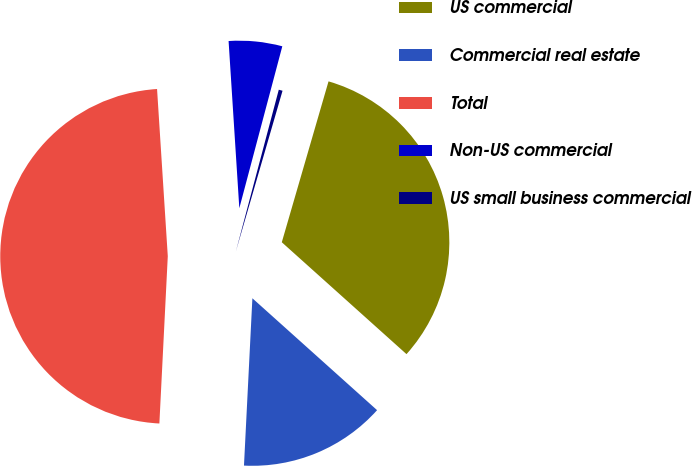<chart> <loc_0><loc_0><loc_500><loc_500><pie_chart><fcel>US commercial<fcel>Commercial real estate<fcel>Total<fcel>Non-US commercial<fcel>US small business commercial<nl><fcel>32.14%<fcel>14.16%<fcel>48.18%<fcel>5.15%<fcel>0.37%<nl></chart> 